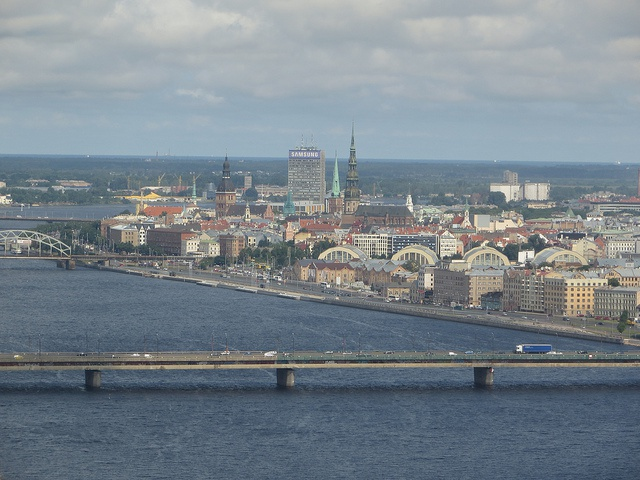Describe the objects in this image and their specific colors. I can see car in darkgray, gray, and blue tones, truck in darkgray, blue, gray, and darkblue tones, car in darkgray, lightgray, and gray tones, car in darkgray, gray, and lightgray tones, and car in darkgray and gray tones in this image. 